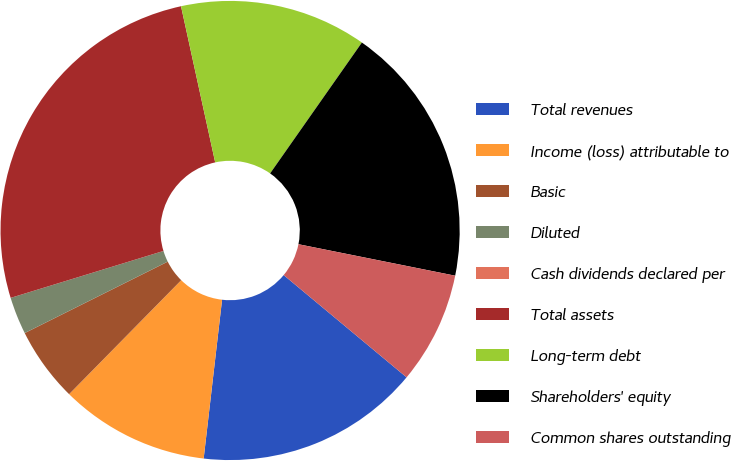Convert chart to OTSL. <chart><loc_0><loc_0><loc_500><loc_500><pie_chart><fcel>Total revenues<fcel>Income (loss) attributable to<fcel>Basic<fcel>Diluted<fcel>Cash dividends declared per<fcel>Total assets<fcel>Long-term debt<fcel>Shareholders' equity<fcel>Common shares outstanding<nl><fcel>15.79%<fcel>10.53%<fcel>5.26%<fcel>2.63%<fcel>0.0%<fcel>26.31%<fcel>13.16%<fcel>18.42%<fcel>7.89%<nl></chart> 